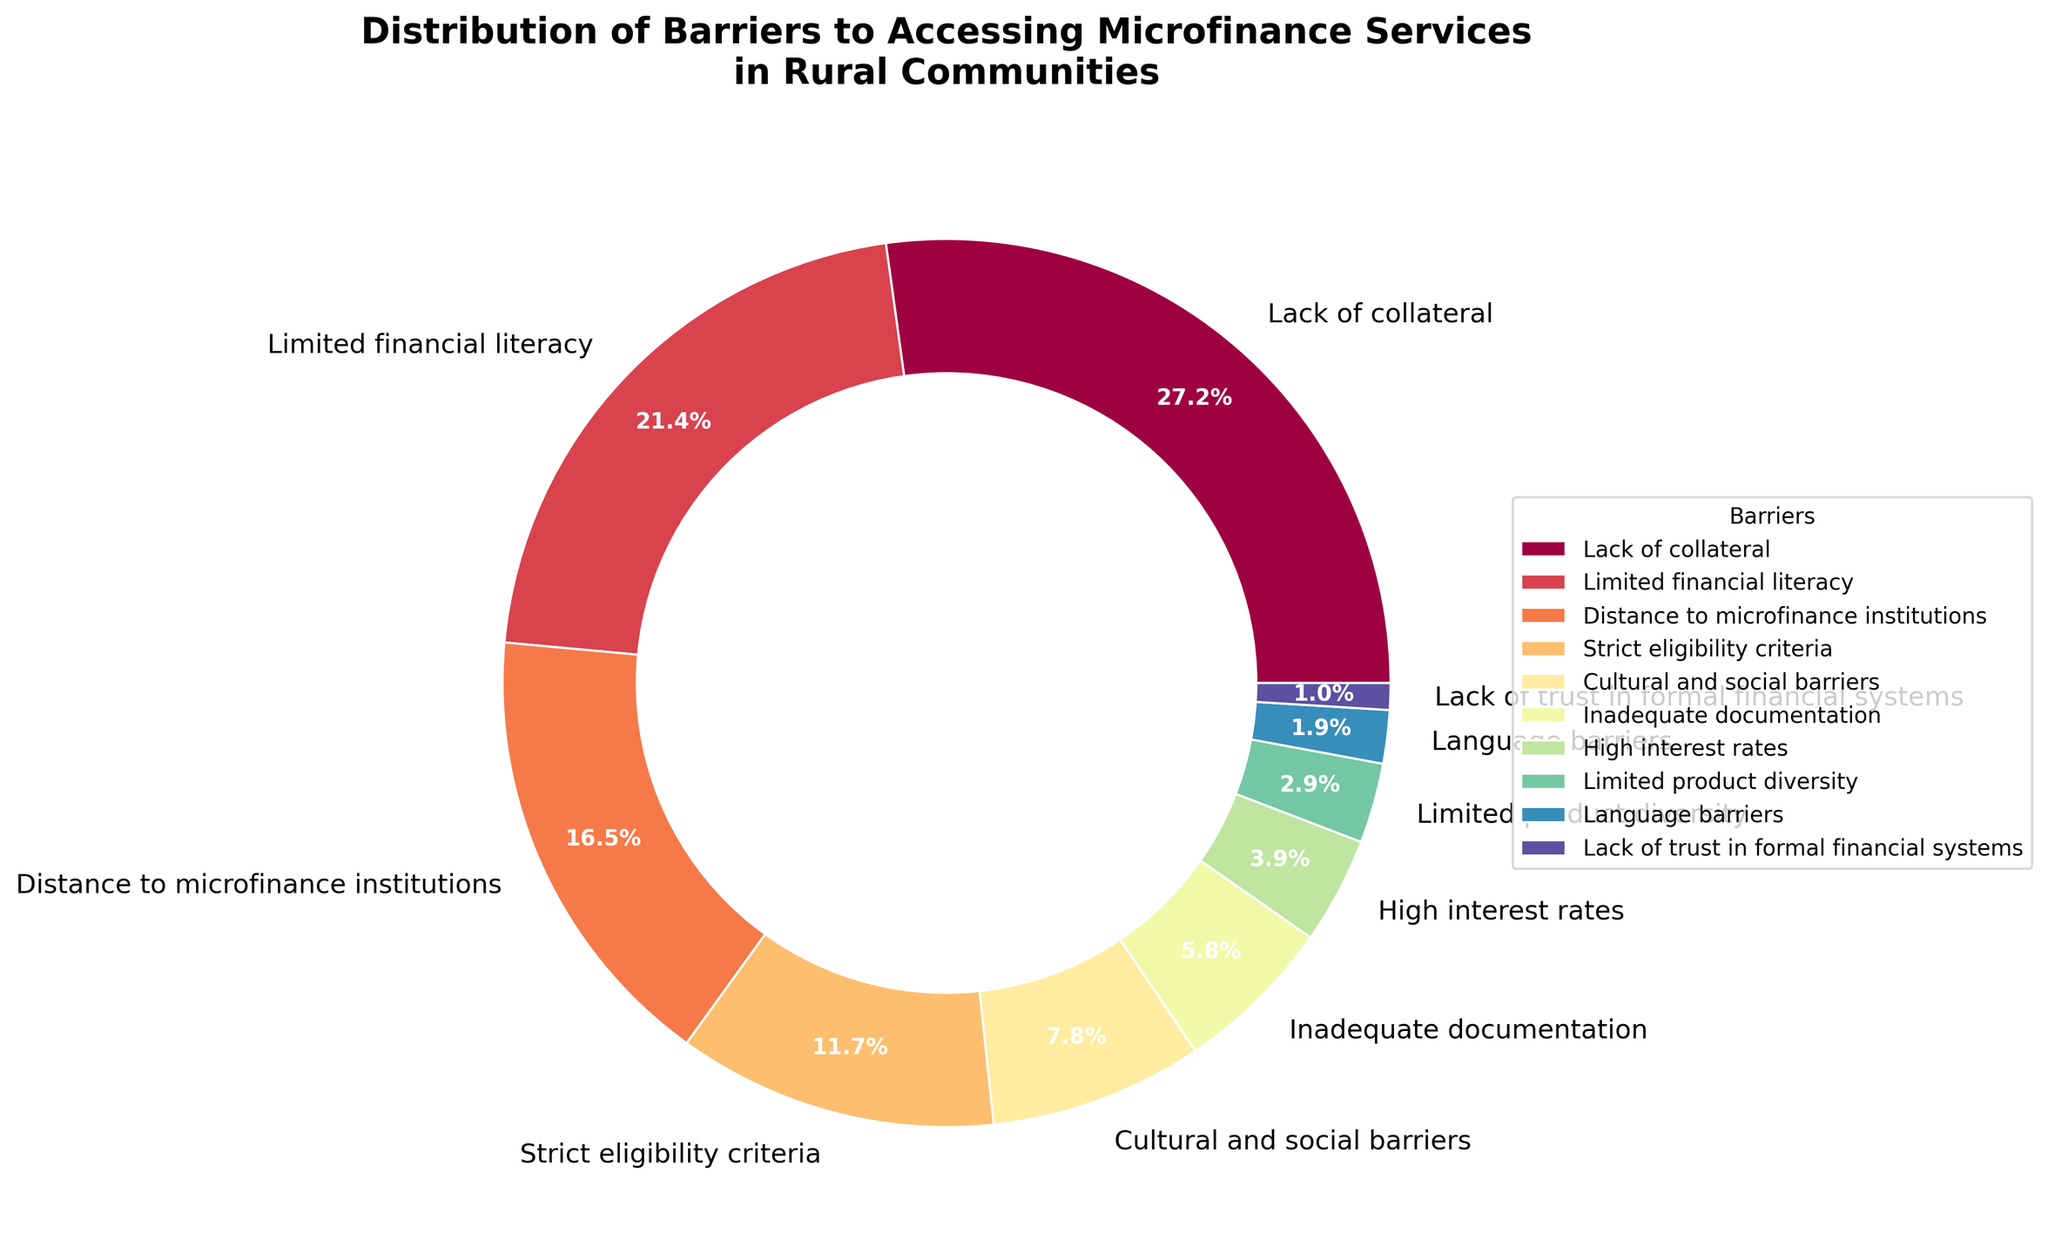Which barrier has the highest percentage? To find the barrier with the highest percentage, look at the segment with the largest size in the pie chart. Here, "Lack of collateral" has the largest section at 28%.
Answer: Lack of collateral Which barriers combined make up more than or equal to half of the total percentage? To determine if a combination of barriers makes up more than half (i.e., more than 50%), start with the largest barrier and keep adding the next largest until the sum is greater than or equal to 50%. "Lack of collateral" (28%) + "Limited financial literacy" (22%) alone already sum to 50%.
Answer: Lack of collateral and Limited financial literacy What is the difference in percentage between the highest and the lowest barrier? The highest barrier is "Lack of collateral" at 28% and the lowest is "Lack of trust in formal financial systems" at 1%. Calculate the difference: 28% - 1% = 27%.
Answer: 27% Which categories together constitute less than 10% of the total percentage? Identify those categories whose individual percentages sum to less than 10%. These are "Limited product diversity" (3%), "Language barriers" (2%), and "Lack of trust in formal financial systems" (1%). Summing them: 3% + 2% + 1% = 6%, which is less than 10%.
Answer: Limited product diversity, Language barriers, Lack of trust in formal financial systems Which barrier is represented by the smallest segment in the pie chart? The smallest segment corresponds to the barrier with the lowest percentage. In this chart, "Lack of trust in formal financial systems" has the smallest segment at 1%.
Answer: Lack of trust in formal financial systems What is the combined percentage of barriers related to eligibility criteria and interest rates? The percentage for "Strict eligibility criteria" is 12% and for "High interest rates" is 4%. Add these together: 12% + 4% = 16%.
Answer: 16% How does the percentage of "Cultural and social barriers" compare with "Distance to microfinance institutions"? The percentage for "Cultural and social barriers" is 8%, while for "Distance to microfinance institutions" it is 17%. 8% is less than 17%.
Answer: Less than Which color represents "Limited financial literacy" in the pie chart? Identify the segment labeled "Limited financial literacy" and note its color. It is important to directly refer to the visual figure to identify the color, but color information is typically encoded with a specific hue.
Answer: [Color corresponding in the visualization] If we sum up the percentages for "Inadequate documentation" and "Language barriers", is the total greater than that for "High interest rates"? The percentage for "Inadequate documentation" is 6% and "Language barriers" is 2%. Adding them: 6% + 2% = 8%. The percentage for "High interest rates" is 4%. Since 8% > 4%, the total is indeed greater.
Answer: Yes Arrange the barriers "Lack of trust in formal financial systems", "Inadequate documentation", and "Strict eligibility criteria" in increasing order of their percentages. The percentage for "Lack of trust in formal financial systems" is 1%, for "Inadequate documentation" is 6%, and for "Strict eligibility criteria" is 12%. Arranging them in increasing order: 1%, 6%, 12%.
Answer: Lack of trust in formal financial systems, Inadequate documentation, Strict eligibility criteria 